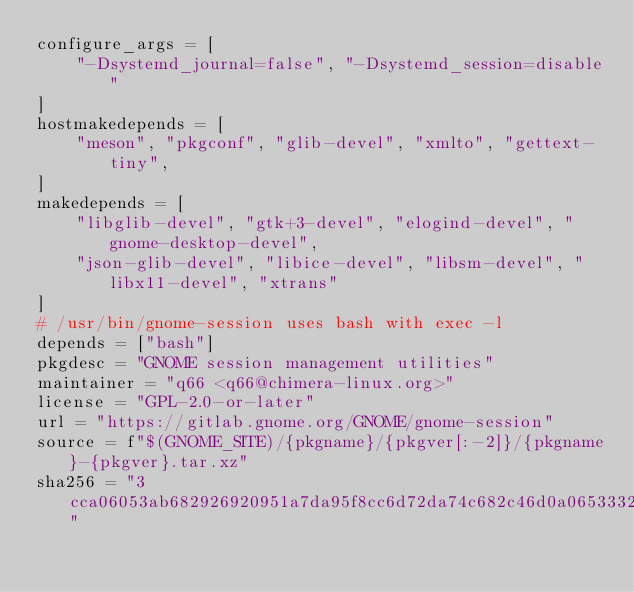Convert code to text. <code><loc_0><loc_0><loc_500><loc_500><_Python_>configure_args = [
    "-Dsystemd_journal=false", "-Dsystemd_session=disable"
]
hostmakedepends = [
    "meson", "pkgconf", "glib-devel", "xmlto", "gettext-tiny",
]
makedepends = [
    "libglib-devel", "gtk+3-devel", "elogind-devel", "gnome-desktop-devel",
    "json-glib-devel", "libice-devel", "libsm-devel", "libx11-devel", "xtrans"
]
# /usr/bin/gnome-session uses bash with exec -l
depends = ["bash"]
pkgdesc = "GNOME session management utilities"
maintainer = "q66 <q66@chimera-linux.org>"
license = "GPL-2.0-or-later"
url = "https://gitlab.gnome.org/GNOME/gnome-session"
source = f"$(GNOME_SITE)/{pkgname}/{pkgver[:-2]}/{pkgname}-{pkgver}.tar.xz"
sha256 = "3cca06053ab682926920951a7da95f8cc6d72da74c682c46d0a0653332969caa"
</code> 